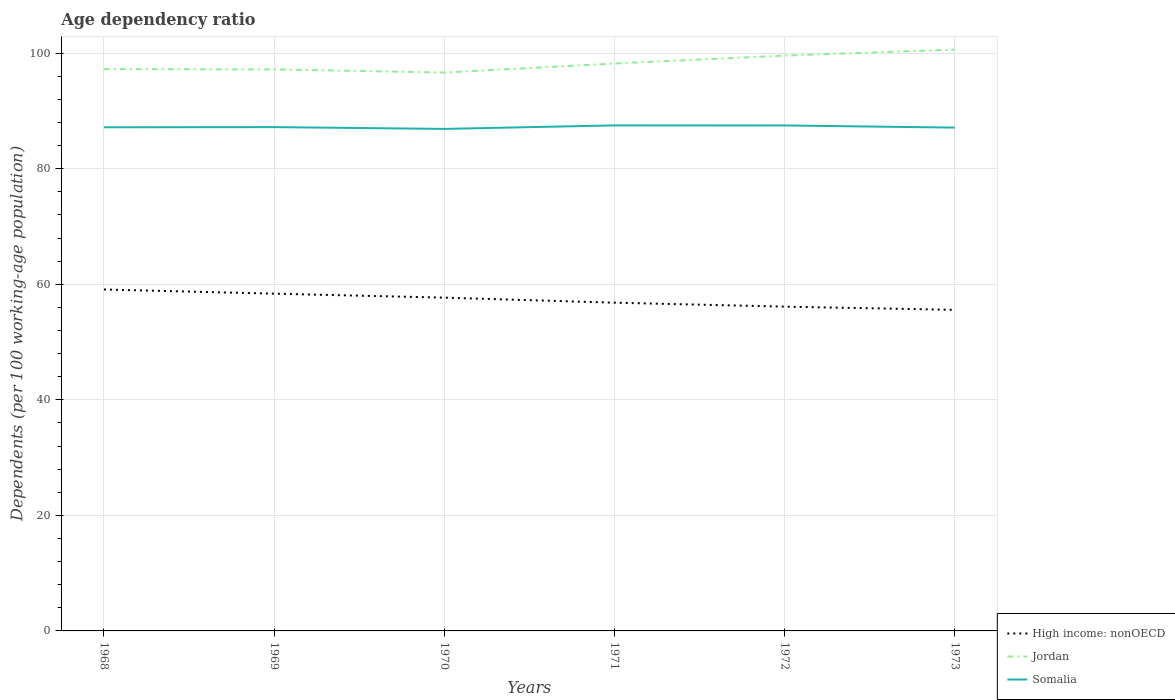How many different coloured lines are there?
Your answer should be very brief. 3. Across all years, what is the maximum age dependency ratio in in Jordan?
Ensure brevity in your answer.  96.63. What is the total age dependency ratio in in Somalia in the graph?
Give a very brief answer. -0.3. What is the difference between the highest and the second highest age dependency ratio in in High income: nonOECD?
Provide a succinct answer. 3.52. Is the age dependency ratio in in High income: nonOECD strictly greater than the age dependency ratio in in Somalia over the years?
Provide a succinct answer. Yes. How many lines are there?
Your answer should be compact. 3. How are the legend labels stacked?
Offer a very short reply. Vertical. What is the title of the graph?
Provide a short and direct response. Age dependency ratio. What is the label or title of the X-axis?
Give a very brief answer. Years. What is the label or title of the Y-axis?
Offer a very short reply. Dependents (per 100 working-age population). What is the Dependents (per 100 working-age population) of High income: nonOECD in 1968?
Your answer should be very brief. 59.09. What is the Dependents (per 100 working-age population) of Jordan in 1968?
Your answer should be compact. 97.23. What is the Dependents (per 100 working-age population) of Somalia in 1968?
Provide a succinct answer. 87.16. What is the Dependents (per 100 working-age population) of High income: nonOECD in 1969?
Offer a very short reply. 58.37. What is the Dependents (per 100 working-age population) in Jordan in 1969?
Ensure brevity in your answer.  97.18. What is the Dependents (per 100 working-age population) in Somalia in 1969?
Give a very brief answer. 87.19. What is the Dependents (per 100 working-age population) of High income: nonOECD in 1970?
Offer a very short reply. 57.68. What is the Dependents (per 100 working-age population) in Jordan in 1970?
Give a very brief answer. 96.63. What is the Dependents (per 100 working-age population) of Somalia in 1970?
Offer a terse response. 86.88. What is the Dependents (per 100 working-age population) in High income: nonOECD in 1971?
Provide a short and direct response. 56.81. What is the Dependents (per 100 working-age population) of Jordan in 1971?
Offer a very short reply. 98.2. What is the Dependents (per 100 working-age population) of Somalia in 1971?
Keep it short and to the point. 87.49. What is the Dependents (per 100 working-age population) in High income: nonOECD in 1972?
Give a very brief answer. 56.12. What is the Dependents (per 100 working-age population) of Jordan in 1972?
Keep it short and to the point. 99.57. What is the Dependents (per 100 working-age population) in Somalia in 1972?
Give a very brief answer. 87.48. What is the Dependents (per 100 working-age population) in High income: nonOECD in 1973?
Your answer should be very brief. 55.56. What is the Dependents (per 100 working-age population) in Jordan in 1973?
Offer a very short reply. 100.61. What is the Dependents (per 100 working-age population) of Somalia in 1973?
Provide a short and direct response. 87.1. Across all years, what is the maximum Dependents (per 100 working-age population) of High income: nonOECD?
Give a very brief answer. 59.09. Across all years, what is the maximum Dependents (per 100 working-age population) of Jordan?
Offer a terse response. 100.61. Across all years, what is the maximum Dependents (per 100 working-age population) of Somalia?
Make the answer very short. 87.49. Across all years, what is the minimum Dependents (per 100 working-age population) of High income: nonOECD?
Keep it short and to the point. 55.56. Across all years, what is the minimum Dependents (per 100 working-age population) of Jordan?
Give a very brief answer. 96.63. Across all years, what is the minimum Dependents (per 100 working-age population) in Somalia?
Offer a very short reply. 86.88. What is the total Dependents (per 100 working-age population) in High income: nonOECD in the graph?
Make the answer very short. 343.62. What is the total Dependents (per 100 working-age population) in Jordan in the graph?
Your answer should be very brief. 589.42. What is the total Dependents (per 100 working-age population) in Somalia in the graph?
Your response must be concise. 523.31. What is the difference between the Dependents (per 100 working-age population) in High income: nonOECD in 1968 and that in 1969?
Offer a very short reply. 0.72. What is the difference between the Dependents (per 100 working-age population) of Jordan in 1968 and that in 1969?
Your answer should be compact. 0.06. What is the difference between the Dependents (per 100 working-age population) of Somalia in 1968 and that in 1969?
Your answer should be compact. -0.03. What is the difference between the Dependents (per 100 working-age population) in High income: nonOECD in 1968 and that in 1970?
Offer a terse response. 1.41. What is the difference between the Dependents (per 100 working-age population) in Jordan in 1968 and that in 1970?
Your answer should be compact. 0.6. What is the difference between the Dependents (per 100 working-age population) of Somalia in 1968 and that in 1970?
Keep it short and to the point. 0.28. What is the difference between the Dependents (per 100 working-age population) in High income: nonOECD in 1968 and that in 1971?
Offer a very short reply. 2.28. What is the difference between the Dependents (per 100 working-age population) of Jordan in 1968 and that in 1971?
Your answer should be compact. -0.96. What is the difference between the Dependents (per 100 working-age population) in Somalia in 1968 and that in 1971?
Offer a very short reply. -0.33. What is the difference between the Dependents (per 100 working-age population) of High income: nonOECD in 1968 and that in 1972?
Offer a terse response. 2.97. What is the difference between the Dependents (per 100 working-age population) in Jordan in 1968 and that in 1972?
Your answer should be very brief. -2.34. What is the difference between the Dependents (per 100 working-age population) of Somalia in 1968 and that in 1972?
Provide a short and direct response. -0.32. What is the difference between the Dependents (per 100 working-age population) of High income: nonOECD in 1968 and that in 1973?
Your answer should be very brief. 3.52. What is the difference between the Dependents (per 100 working-age population) in Jordan in 1968 and that in 1973?
Your response must be concise. -3.37. What is the difference between the Dependents (per 100 working-age population) of Somalia in 1968 and that in 1973?
Ensure brevity in your answer.  0.06. What is the difference between the Dependents (per 100 working-age population) in High income: nonOECD in 1969 and that in 1970?
Make the answer very short. 0.69. What is the difference between the Dependents (per 100 working-age population) in Jordan in 1969 and that in 1970?
Offer a terse response. 0.54. What is the difference between the Dependents (per 100 working-age population) in Somalia in 1969 and that in 1970?
Your answer should be very brief. 0.31. What is the difference between the Dependents (per 100 working-age population) in High income: nonOECD in 1969 and that in 1971?
Provide a short and direct response. 1.56. What is the difference between the Dependents (per 100 working-age population) of Jordan in 1969 and that in 1971?
Your response must be concise. -1.02. What is the difference between the Dependents (per 100 working-age population) of Somalia in 1969 and that in 1971?
Keep it short and to the point. -0.3. What is the difference between the Dependents (per 100 working-age population) of High income: nonOECD in 1969 and that in 1972?
Give a very brief answer. 2.25. What is the difference between the Dependents (per 100 working-age population) of Jordan in 1969 and that in 1972?
Ensure brevity in your answer.  -2.39. What is the difference between the Dependents (per 100 working-age population) of Somalia in 1969 and that in 1972?
Offer a terse response. -0.29. What is the difference between the Dependents (per 100 working-age population) in High income: nonOECD in 1969 and that in 1973?
Make the answer very short. 2.8. What is the difference between the Dependents (per 100 working-age population) in Jordan in 1969 and that in 1973?
Provide a succinct answer. -3.43. What is the difference between the Dependents (per 100 working-age population) of Somalia in 1969 and that in 1973?
Provide a succinct answer. 0.09. What is the difference between the Dependents (per 100 working-age population) of High income: nonOECD in 1970 and that in 1971?
Ensure brevity in your answer.  0.87. What is the difference between the Dependents (per 100 working-age population) in Jordan in 1970 and that in 1971?
Provide a short and direct response. -1.56. What is the difference between the Dependents (per 100 working-age population) in Somalia in 1970 and that in 1971?
Make the answer very short. -0.61. What is the difference between the Dependents (per 100 working-age population) of High income: nonOECD in 1970 and that in 1972?
Provide a short and direct response. 1.56. What is the difference between the Dependents (per 100 working-age population) in Jordan in 1970 and that in 1972?
Give a very brief answer. -2.94. What is the difference between the Dependents (per 100 working-age population) of Somalia in 1970 and that in 1972?
Your response must be concise. -0.6. What is the difference between the Dependents (per 100 working-age population) in High income: nonOECD in 1970 and that in 1973?
Provide a succinct answer. 2.11. What is the difference between the Dependents (per 100 working-age population) in Jordan in 1970 and that in 1973?
Ensure brevity in your answer.  -3.97. What is the difference between the Dependents (per 100 working-age population) in Somalia in 1970 and that in 1973?
Provide a succinct answer. -0.22. What is the difference between the Dependents (per 100 working-age population) in High income: nonOECD in 1971 and that in 1972?
Offer a very short reply. 0.69. What is the difference between the Dependents (per 100 working-age population) of Jordan in 1971 and that in 1972?
Offer a terse response. -1.37. What is the difference between the Dependents (per 100 working-age population) in Somalia in 1971 and that in 1972?
Offer a terse response. 0.01. What is the difference between the Dependents (per 100 working-age population) of High income: nonOECD in 1971 and that in 1973?
Your answer should be very brief. 1.24. What is the difference between the Dependents (per 100 working-age population) of Jordan in 1971 and that in 1973?
Ensure brevity in your answer.  -2.41. What is the difference between the Dependents (per 100 working-age population) of Somalia in 1971 and that in 1973?
Offer a terse response. 0.39. What is the difference between the Dependents (per 100 working-age population) in High income: nonOECD in 1972 and that in 1973?
Provide a succinct answer. 0.56. What is the difference between the Dependents (per 100 working-age population) of Jordan in 1972 and that in 1973?
Make the answer very short. -1.04. What is the difference between the Dependents (per 100 working-age population) in Somalia in 1972 and that in 1973?
Your answer should be very brief. 0.38. What is the difference between the Dependents (per 100 working-age population) of High income: nonOECD in 1968 and the Dependents (per 100 working-age population) of Jordan in 1969?
Offer a very short reply. -38.09. What is the difference between the Dependents (per 100 working-age population) in High income: nonOECD in 1968 and the Dependents (per 100 working-age population) in Somalia in 1969?
Your answer should be compact. -28.11. What is the difference between the Dependents (per 100 working-age population) in Jordan in 1968 and the Dependents (per 100 working-age population) in Somalia in 1969?
Offer a terse response. 10.04. What is the difference between the Dependents (per 100 working-age population) in High income: nonOECD in 1968 and the Dependents (per 100 working-age population) in Jordan in 1970?
Your answer should be compact. -37.55. What is the difference between the Dependents (per 100 working-age population) of High income: nonOECD in 1968 and the Dependents (per 100 working-age population) of Somalia in 1970?
Offer a very short reply. -27.79. What is the difference between the Dependents (per 100 working-age population) in Jordan in 1968 and the Dependents (per 100 working-age population) in Somalia in 1970?
Your response must be concise. 10.35. What is the difference between the Dependents (per 100 working-age population) in High income: nonOECD in 1968 and the Dependents (per 100 working-age population) in Jordan in 1971?
Offer a very short reply. -39.11. What is the difference between the Dependents (per 100 working-age population) of High income: nonOECD in 1968 and the Dependents (per 100 working-age population) of Somalia in 1971?
Keep it short and to the point. -28.4. What is the difference between the Dependents (per 100 working-age population) of Jordan in 1968 and the Dependents (per 100 working-age population) of Somalia in 1971?
Offer a very short reply. 9.74. What is the difference between the Dependents (per 100 working-age population) in High income: nonOECD in 1968 and the Dependents (per 100 working-age population) in Jordan in 1972?
Offer a very short reply. -40.48. What is the difference between the Dependents (per 100 working-age population) in High income: nonOECD in 1968 and the Dependents (per 100 working-age population) in Somalia in 1972?
Your answer should be very brief. -28.39. What is the difference between the Dependents (per 100 working-age population) in Jordan in 1968 and the Dependents (per 100 working-age population) in Somalia in 1972?
Provide a short and direct response. 9.75. What is the difference between the Dependents (per 100 working-age population) in High income: nonOECD in 1968 and the Dependents (per 100 working-age population) in Jordan in 1973?
Offer a very short reply. -41.52. What is the difference between the Dependents (per 100 working-age population) of High income: nonOECD in 1968 and the Dependents (per 100 working-age population) of Somalia in 1973?
Give a very brief answer. -28.02. What is the difference between the Dependents (per 100 working-age population) of Jordan in 1968 and the Dependents (per 100 working-age population) of Somalia in 1973?
Offer a terse response. 10.13. What is the difference between the Dependents (per 100 working-age population) of High income: nonOECD in 1969 and the Dependents (per 100 working-age population) of Jordan in 1970?
Keep it short and to the point. -38.27. What is the difference between the Dependents (per 100 working-age population) in High income: nonOECD in 1969 and the Dependents (per 100 working-age population) in Somalia in 1970?
Offer a terse response. -28.51. What is the difference between the Dependents (per 100 working-age population) in Jordan in 1969 and the Dependents (per 100 working-age population) in Somalia in 1970?
Ensure brevity in your answer.  10.3. What is the difference between the Dependents (per 100 working-age population) of High income: nonOECD in 1969 and the Dependents (per 100 working-age population) of Jordan in 1971?
Your response must be concise. -39.83. What is the difference between the Dependents (per 100 working-age population) of High income: nonOECD in 1969 and the Dependents (per 100 working-age population) of Somalia in 1971?
Give a very brief answer. -29.12. What is the difference between the Dependents (per 100 working-age population) of Jordan in 1969 and the Dependents (per 100 working-age population) of Somalia in 1971?
Your answer should be very brief. 9.69. What is the difference between the Dependents (per 100 working-age population) of High income: nonOECD in 1969 and the Dependents (per 100 working-age population) of Jordan in 1972?
Your answer should be compact. -41.2. What is the difference between the Dependents (per 100 working-age population) of High income: nonOECD in 1969 and the Dependents (per 100 working-age population) of Somalia in 1972?
Ensure brevity in your answer.  -29.11. What is the difference between the Dependents (per 100 working-age population) in Jordan in 1969 and the Dependents (per 100 working-age population) in Somalia in 1972?
Ensure brevity in your answer.  9.7. What is the difference between the Dependents (per 100 working-age population) of High income: nonOECD in 1969 and the Dependents (per 100 working-age population) of Jordan in 1973?
Keep it short and to the point. -42.24. What is the difference between the Dependents (per 100 working-age population) in High income: nonOECD in 1969 and the Dependents (per 100 working-age population) in Somalia in 1973?
Make the answer very short. -28.74. What is the difference between the Dependents (per 100 working-age population) in Jordan in 1969 and the Dependents (per 100 working-age population) in Somalia in 1973?
Make the answer very short. 10.07. What is the difference between the Dependents (per 100 working-age population) of High income: nonOECD in 1970 and the Dependents (per 100 working-age population) of Jordan in 1971?
Ensure brevity in your answer.  -40.52. What is the difference between the Dependents (per 100 working-age population) of High income: nonOECD in 1970 and the Dependents (per 100 working-age population) of Somalia in 1971?
Your response must be concise. -29.81. What is the difference between the Dependents (per 100 working-age population) of Jordan in 1970 and the Dependents (per 100 working-age population) of Somalia in 1971?
Give a very brief answer. 9.14. What is the difference between the Dependents (per 100 working-age population) in High income: nonOECD in 1970 and the Dependents (per 100 working-age population) in Jordan in 1972?
Make the answer very short. -41.9. What is the difference between the Dependents (per 100 working-age population) of High income: nonOECD in 1970 and the Dependents (per 100 working-age population) of Somalia in 1972?
Give a very brief answer. -29.8. What is the difference between the Dependents (per 100 working-age population) in Jordan in 1970 and the Dependents (per 100 working-age population) in Somalia in 1972?
Your answer should be very brief. 9.15. What is the difference between the Dependents (per 100 working-age population) of High income: nonOECD in 1970 and the Dependents (per 100 working-age population) of Jordan in 1973?
Provide a short and direct response. -42.93. What is the difference between the Dependents (per 100 working-age population) in High income: nonOECD in 1970 and the Dependents (per 100 working-age population) in Somalia in 1973?
Make the answer very short. -29.43. What is the difference between the Dependents (per 100 working-age population) of Jordan in 1970 and the Dependents (per 100 working-age population) of Somalia in 1973?
Offer a very short reply. 9.53. What is the difference between the Dependents (per 100 working-age population) of High income: nonOECD in 1971 and the Dependents (per 100 working-age population) of Jordan in 1972?
Offer a very short reply. -42.76. What is the difference between the Dependents (per 100 working-age population) in High income: nonOECD in 1971 and the Dependents (per 100 working-age population) in Somalia in 1972?
Make the answer very short. -30.67. What is the difference between the Dependents (per 100 working-age population) of Jordan in 1971 and the Dependents (per 100 working-age population) of Somalia in 1972?
Provide a succinct answer. 10.72. What is the difference between the Dependents (per 100 working-age population) of High income: nonOECD in 1971 and the Dependents (per 100 working-age population) of Jordan in 1973?
Provide a short and direct response. -43.8. What is the difference between the Dependents (per 100 working-age population) of High income: nonOECD in 1971 and the Dependents (per 100 working-age population) of Somalia in 1973?
Give a very brief answer. -30.3. What is the difference between the Dependents (per 100 working-age population) of Jordan in 1971 and the Dependents (per 100 working-age population) of Somalia in 1973?
Make the answer very short. 11.09. What is the difference between the Dependents (per 100 working-age population) of High income: nonOECD in 1972 and the Dependents (per 100 working-age population) of Jordan in 1973?
Your response must be concise. -44.49. What is the difference between the Dependents (per 100 working-age population) of High income: nonOECD in 1972 and the Dependents (per 100 working-age population) of Somalia in 1973?
Give a very brief answer. -30.98. What is the difference between the Dependents (per 100 working-age population) of Jordan in 1972 and the Dependents (per 100 working-age population) of Somalia in 1973?
Make the answer very short. 12.47. What is the average Dependents (per 100 working-age population) of High income: nonOECD per year?
Give a very brief answer. 57.27. What is the average Dependents (per 100 working-age population) of Jordan per year?
Provide a short and direct response. 98.24. What is the average Dependents (per 100 working-age population) in Somalia per year?
Keep it short and to the point. 87.22. In the year 1968, what is the difference between the Dependents (per 100 working-age population) in High income: nonOECD and Dependents (per 100 working-age population) in Jordan?
Give a very brief answer. -38.15. In the year 1968, what is the difference between the Dependents (per 100 working-age population) in High income: nonOECD and Dependents (per 100 working-age population) in Somalia?
Provide a short and direct response. -28.08. In the year 1968, what is the difference between the Dependents (per 100 working-age population) of Jordan and Dependents (per 100 working-age population) of Somalia?
Provide a short and direct response. 10.07. In the year 1969, what is the difference between the Dependents (per 100 working-age population) in High income: nonOECD and Dependents (per 100 working-age population) in Jordan?
Your response must be concise. -38.81. In the year 1969, what is the difference between the Dependents (per 100 working-age population) of High income: nonOECD and Dependents (per 100 working-age population) of Somalia?
Your answer should be compact. -28.83. In the year 1969, what is the difference between the Dependents (per 100 working-age population) of Jordan and Dependents (per 100 working-age population) of Somalia?
Offer a terse response. 9.98. In the year 1970, what is the difference between the Dependents (per 100 working-age population) of High income: nonOECD and Dependents (per 100 working-age population) of Jordan?
Your answer should be compact. -38.96. In the year 1970, what is the difference between the Dependents (per 100 working-age population) of High income: nonOECD and Dependents (per 100 working-age population) of Somalia?
Offer a very short reply. -29.2. In the year 1970, what is the difference between the Dependents (per 100 working-age population) in Jordan and Dependents (per 100 working-age population) in Somalia?
Make the answer very short. 9.75. In the year 1971, what is the difference between the Dependents (per 100 working-age population) in High income: nonOECD and Dependents (per 100 working-age population) in Jordan?
Offer a terse response. -41.39. In the year 1971, what is the difference between the Dependents (per 100 working-age population) of High income: nonOECD and Dependents (per 100 working-age population) of Somalia?
Give a very brief answer. -30.68. In the year 1971, what is the difference between the Dependents (per 100 working-age population) of Jordan and Dependents (per 100 working-age population) of Somalia?
Give a very brief answer. 10.71. In the year 1972, what is the difference between the Dependents (per 100 working-age population) of High income: nonOECD and Dependents (per 100 working-age population) of Jordan?
Make the answer very short. -43.45. In the year 1972, what is the difference between the Dependents (per 100 working-age population) of High income: nonOECD and Dependents (per 100 working-age population) of Somalia?
Make the answer very short. -31.36. In the year 1972, what is the difference between the Dependents (per 100 working-age population) in Jordan and Dependents (per 100 working-age population) in Somalia?
Keep it short and to the point. 12.09. In the year 1973, what is the difference between the Dependents (per 100 working-age population) of High income: nonOECD and Dependents (per 100 working-age population) of Jordan?
Your answer should be very brief. -45.04. In the year 1973, what is the difference between the Dependents (per 100 working-age population) in High income: nonOECD and Dependents (per 100 working-age population) in Somalia?
Provide a short and direct response. -31.54. In the year 1973, what is the difference between the Dependents (per 100 working-age population) in Jordan and Dependents (per 100 working-age population) in Somalia?
Keep it short and to the point. 13.5. What is the ratio of the Dependents (per 100 working-age population) of High income: nonOECD in 1968 to that in 1969?
Make the answer very short. 1.01. What is the ratio of the Dependents (per 100 working-age population) of Jordan in 1968 to that in 1969?
Give a very brief answer. 1. What is the ratio of the Dependents (per 100 working-age population) in High income: nonOECD in 1968 to that in 1970?
Ensure brevity in your answer.  1.02. What is the ratio of the Dependents (per 100 working-age population) of High income: nonOECD in 1968 to that in 1971?
Keep it short and to the point. 1.04. What is the ratio of the Dependents (per 100 working-age population) in Jordan in 1968 to that in 1971?
Provide a short and direct response. 0.99. What is the ratio of the Dependents (per 100 working-age population) in High income: nonOECD in 1968 to that in 1972?
Offer a very short reply. 1.05. What is the ratio of the Dependents (per 100 working-age population) of Jordan in 1968 to that in 1972?
Ensure brevity in your answer.  0.98. What is the ratio of the Dependents (per 100 working-age population) in Somalia in 1968 to that in 1972?
Make the answer very short. 1. What is the ratio of the Dependents (per 100 working-age population) in High income: nonOECD in 1968 to that in 1973?
Your answer should be very brief. 1.06. What is the ratio of the Dependents (per 100 working-age population) of Jordan in 1968 to that in 1973?
Your answer should be very brief. 0.97. What is the ratio of the Dependents (per 100 working-age population) of High income: nonOECD in 1969 to that in 1970?
Offer a very short reply. 1.01. What is the ratio of the Dependents (per 100 working-age population) in Jordan in 1969 to that in 1970?
Ensure brevity in your answer.  1.01. What is the ratio of the Dependents (per 100 working-age population) in Somalia in 1969 to that in 1970?
Provide a short and direct response. 1. What is the ratio of the Dependents (per 100 working-age population) of High income: nonOECD in 1969 to that in 1971?
Offer a very short reply. 1.03. What is the ratio of the Dependents (per 100 working-age population) of Jordan in 1969 to that in 1971?
Ensure brevity in your answer.  0.99. What is the ratio of the Dependents (per 100 working-age population) of Somalia in 1969 to that in 1972?
Your answer should be compact. 1. What is the ratio of the Dependents (per 100 working-age population) of High income: nonOECD in 1969 to that in 1973?
Make the answer very short. 1.05. What is the ratio of the Dependents (per 100 working-age population) of Jordan in 1969 to that in 1973?
Give a very brief answer. 0.97. What is the ratio of the Dependents (per 100 working-age population) of Somalia in 1969 to that in 1973?
Your answer should be very brief. 1. What is the ratio of the Dependents (per 100 working-age population) in High income: nonOECD in 1970 to that in 1971?
Your response must be concise. 1.02. What is the ratio of the Dependents (per 100 working-age population) of Jordan in 1970 to that in 1971?
Offer a terse response. 0.98. What is the ratio of the Dependents (per 100 working-age population) of High income: nonOECD in 1970 to that in 1972?
Give a very brief answer. 1.03. What is the ratio of the Dependents (per 100 working-age population) of Jordan in 1970 to that in 1972?
Ensure brevity in your answer.  0.97. What is the ratio of the Dependents (per 100 working-age population) of High income: nonOECD in 1970 to that in 1973?
Provide a succinct answer. 1.04. What is the ratio of the Dependents (per 100 working-age population) of Jordan in 1970 to that in 1973?
Ensure brevity in your answer.  0.96. What is the ratio of the Dependents (per 100 working-age population) of High income: nonOECD in 1971 to that in 1972?
Provide a succinct answer. 1.01. What is the ratio of the Dependents (per 100 working-age population) in Jordan in 1971 to that in 1972?
Your answer should be very brief. 0.99. What is the ratio of the Dependents (per 100 working-age population) of Somalia in 1971 to that in 1972?
Offer a terse response. 1. What is the ratio of the Dependents (per 100 working-age population) of High income: nonOECD in 1971 to that in 1973?
Your answer should be compact. 1.02. What is the ratio of the Dependents (per 100 working-age population) in Jordan in 1971 to that in 1973?
Provide a short and direct response. 0.98. What is the ratio of the Dependents (per 100 working-age population) in Somalia in 1971 to that in 1973?
Provide a succinct answer. 1. What is the ratio of the Dependents (per 100 working-age population) in High income: nonOECD in 1972 to that in 1973?
Your response must be concise. 1.01. What is the difference between the highest and the second highest Dependents (per 100 working-age population) in High income: nonOECD?
Give a very brief answer. 0.72. What is the difference between the highest and the second highest Dependents (per 100 working-age population) in Jordan?
Give a very brief answer. 1.04. What is the difference between the highest and the second highest Dependents (per 100 working-age population) of Somalia?
Your answer should be very brief. 0.01. What is the difference between the highest and the lowest Dependents (per 100 working-age population) of High income: nonOECD?
Your answer should be very brief. 3.52. What is the difference between the highest and the lowest Dependents (per 100 working-age population) in Jordan?
Ensure brevity in your answer.  3.97. What is the difference between the highest and the lowest Dependents (per 100 working-age population) of Somalia?
Provide a succinct answer. 0.61. 